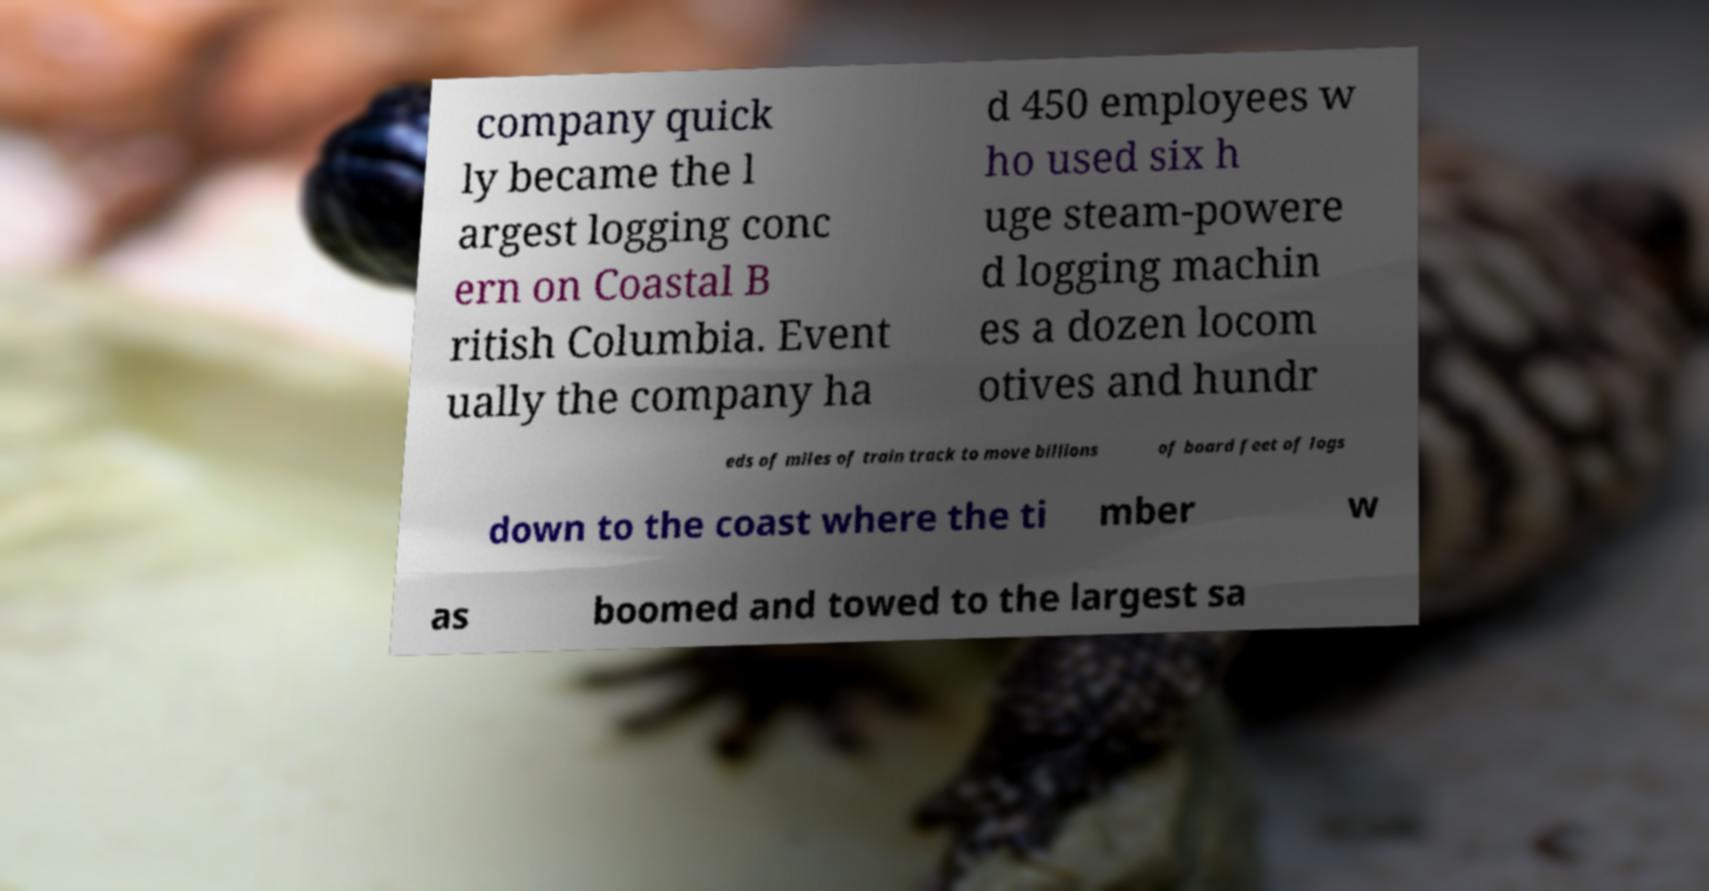Can you accurately transcribe the text from the provided image for me? company quick ly became the l argest logging conc ern on Coastal B ritish Columbia. Event ually the company ha d 450 employees w ho used six h uge steam-powere d logging machin es a dozen locom otives and hundr eds of miles of train track to move billions of board feet of logs down to the coast where the ti mber w as boomed and towed to the largest sa 